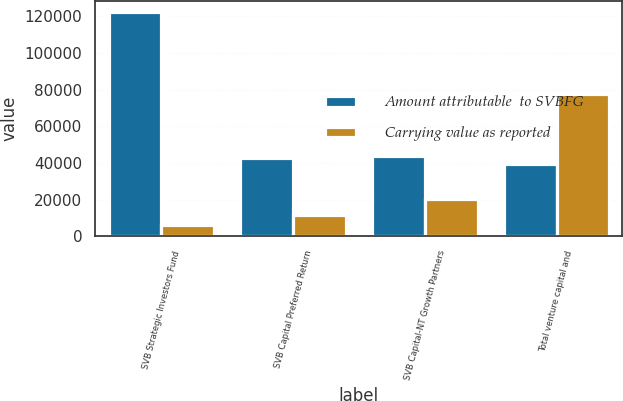<chart> <loc_0><loc_0><loc_500><loc_500><stacked_bar_chart><ecel><fcel>SVB Strategic Investors Fund<fcel>SVB Capital Preferred Return<fcel>SVB Capital-NT Growth Partners<fcel>Total venture capital and<nl><fcel>Amount attributable  to SVBFG<fcel>122076<fcel>42580<fcel>43958<fcel>39567<nl><fcel>Carrying value as reported<fcel>6104<fcel>11571<fcel>20176<fcel>77674<nl></chart> 